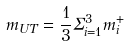<formula> <loc_0><loc_0><loc_500><loc_500>m _ { U T } = \frac { 1 } { 3 } \Sigma _ { i = 1 } ^ { 3 } m _ { i } ^ { + }</formula> 